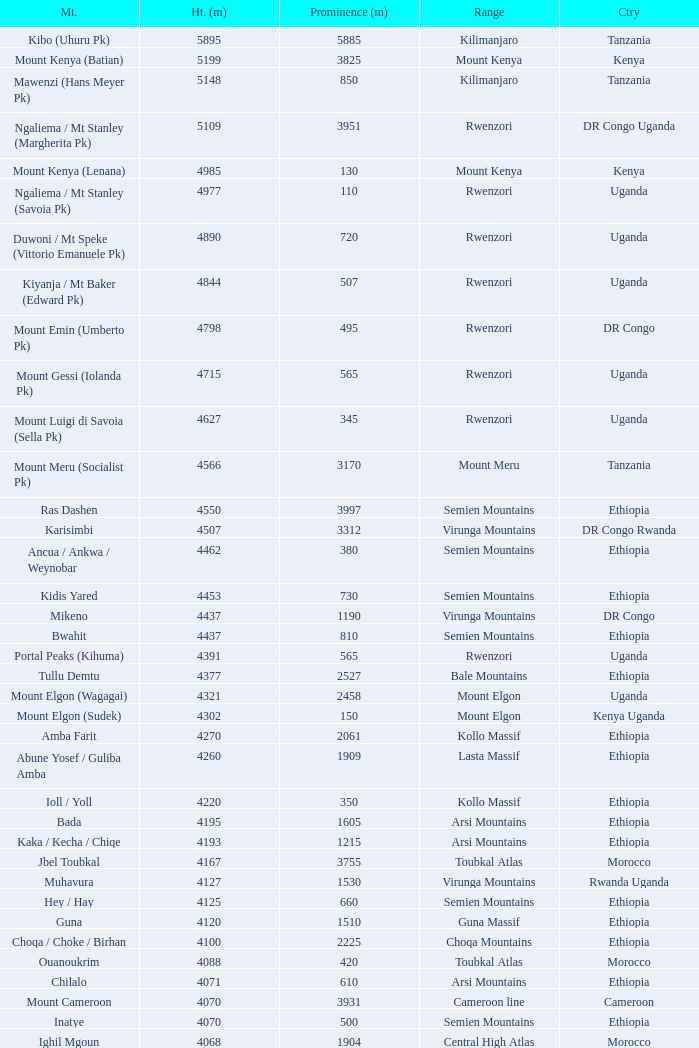How tall is the Mountain of jbel ghat? 1.0. 